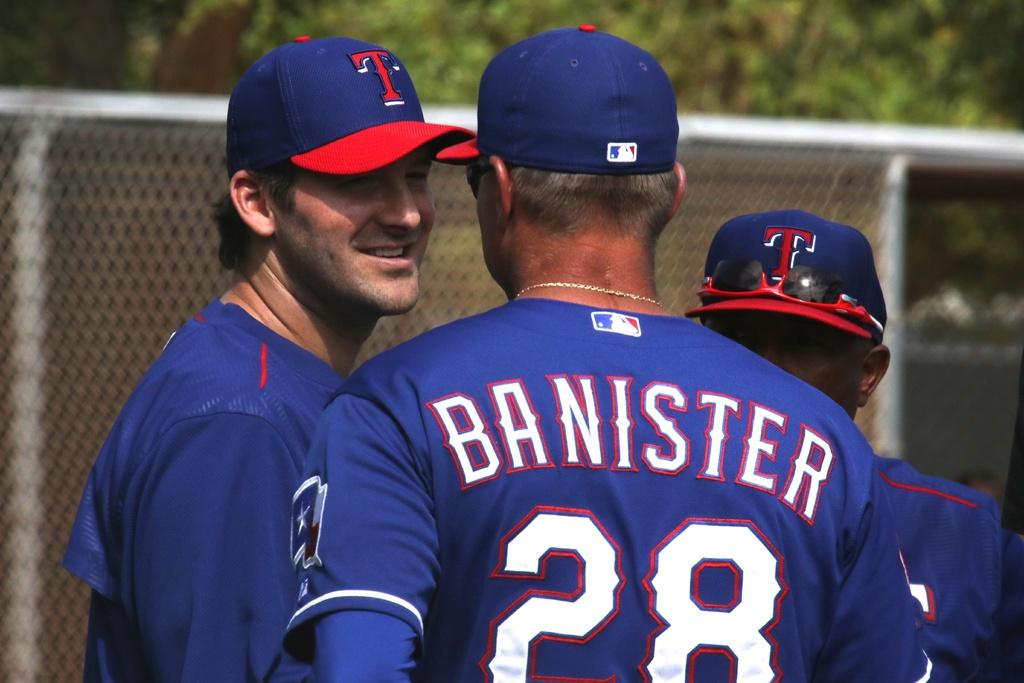<image>
Provide a brief description of the given image. A baseball player has the name Banister on his jersey. 